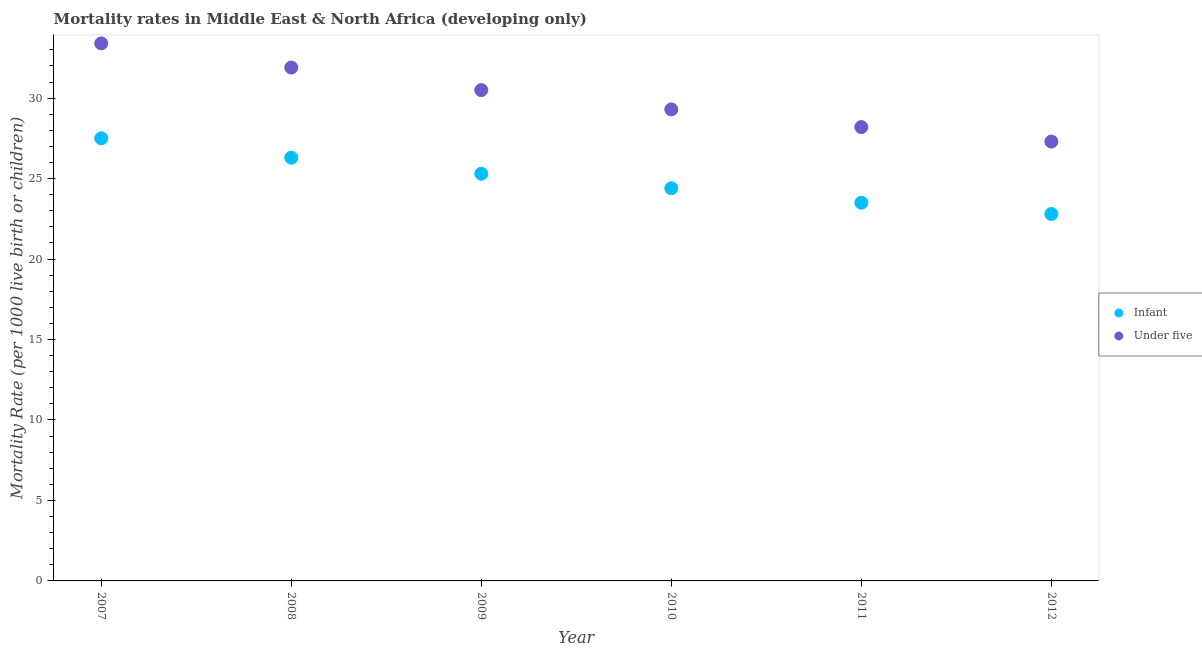How many different coloured dotlines are there?
Keep it short and to the point. 2. Is the number of dotlines equal to the number of legend labels?
Your response must be concise. Yes. What is the under-5 mortality rate in 2011?
Ensure brevity in your answer.  28.2. Across all years, what is the maximum under-5 mortality rate?
Your response must be concise. 33.4. Across all years, what is the minimum under-5 mortality rate?
Provide a short and direct response. 27.3. In which year was the infant mortality rate maximum?
Keep it short and to the point. 2007. What is the total under-5 mortality rate in the graph?
Your answer should be compact. 180.6. What is the difference between the under-5 mortality rate in 2008 and that in 2012?
Your answer should be compact. 4.6. What is the average infant mortality rate per year?
Make the answer very short. 24.97. In the year 2011, what is the difference between the infant mortality rate and under-5 mortality rate?
Make the answer very short. -4.7. In how many years, is the under-5 mortality rate greater than 10?
Provide a succinct answer. 6. What is the ratio of the under-5 mortality rate in 2008 to that in 2009?
Keep it short and to the point. 1.05. Is the difference between the under-5 mortality rate in 2008 and 2011 greater than the difference between the infant mortality rate in 2008 and 2011?
Provide a short and direct response. Yes. What is the difference between the highest and the second highest infant mortality rate?
Offer a very short reply. 1.2. What is the difference between the highest and the lowest under-5 mortality rate?
Your answer should be very brief. 6.1. In how many years, is the under-5 mortality rate greater than the average under-5 mortality rate taken over all years?
Your answer should be very brief. 3. Is the sum of the under-5 mortality rate in 2008 and 2009 greater than the maximum infant mortality rate across all years?
Make the answer very short. Yes. Does the infant mortality rate monotonically increase over the years?
Your answer should be very brief. No. Is the under-5 mortality rate strictly greater than the infant mortality rate over the years?
Ensure brevity in your answer.  Yes. How many dotlines are there?
Ensure brevity in your answer.  2. How many years are there in the graph?
Make the answer very short. 6. How are the legend labels stacked?
Give a very brief answer. Vertical. What is the title of the graph?
Give a very brief answer. Mortality rates in Middle East & North Africa (developing only). Does "2012 US$" appear as one of the legend labels in the graph?
Your response must be concise. No. What is the label or title of the Y-axis?
Ensure brevity in your answer.  Mortality Rate (per 1000 live birth or children). What is the Mortality Rate (per 1000 live birth or children) in Under five in 2007?
Your response must be concise. 33.4. What is the Mortality Rate (per 1000 live birth or children) of Infant in 2008?
Give a very brief answer. 26.3. What is the Mortality Rate (per 1000 live birth or children) in Under five in 2008?
Offer a terse response. 31.9. What is the Mortality Rate (per 1000 live birth or children) in Infant in 2009?
Your response must be concise. 25.3. What is the Mortality Rate (per 1000 live birth or children) of Under five in 2009?
Make the answer very short. 30.5. What is the Mortality Rate (per 1000 live birth or children) in Infant in 2010?
Keep it short and to the point. 24.4. What is the Mortality Rate (per 1000 live birth or children) of Under five in 2010?
Your response must be concise. 29.3. What is the Mortality Rate (per 1000 live birth or children) in Infant in 2011?
Give a very brief answer. 23.5. What is the Mortality Rate (per 1000 live birth or children) of Under five in 2011?
Offer a very short reply. 28.2. What is the Mortality Rate (per 1000 live birth or children) in Infant in 2012?
Ensure brevity in your answer.  22.8. What is the Mortality Rate (per 1000 live birth or children) in Under five in 2012?
Your answer should be compact. 27.3. Across all years, what is the maximum Mortality Rate (per 1000 live birth or children) of Infant?
Offer a very short reply. 27.5. Across all years, what is the maximum Mortality Rate (per 1000 live birth or children) of Under five?
Ensure brevity in your answer.  33.4. Across all years, what is the minimum Mortality Rate (per 1000 live birth or children) in Infant?
Provide a short and direct response. 22.8. Across all years, what is the minimum Mortality Rate (per 1000 live birth or children) in Under five?
Offer a very short reply. 27.3. What is the total Mortality Rate (per 1000 live birth or children) of Infant in the graph?
Your answer should be compact. 149.8. What is the total Mortality Rate (per 1000 live birth or children) in Under five in the graph?
Keep it short and to the point. 180.6. What is the difference between the Mortality Rate (per 1000 live birth or children) of Under five in 2007 and that in 2008?
Provide a succinct answer. 1.5. What is the difference between the Mortality Rate (per 1000 live birth or children) in Infant in 2007 and that in 2010?
Your answer should be very brief. 3.1. What is the difference between the Mortality Rate (per 1000 live birth or children) in Under five in 2007 and that in 2010?
Give a very brief answer. 4.1. What is the difference between the Mortality Rate (per 1000 live birth or children) of Under five in 2007 and that in 2011?
Make the answer very short. 5.2. What is the difference between the Mortality Rate (per 1000 live birth or children) of Infant in 2007 and that in 2012?
Give a very brief answer. 4.7. What is the difference between the Mortality Rate (per 1000 live birth or children) of Under five in 2007 and that in 2012?
Ensure brevity in your answer.  6.1. What is the difference between the Mortality Rate (per 1000 live birth or children) in Infant in 2008 and that in 2009?
Provide a succinct answer. 1. What is the difference between the Mortality Rate (per 1000 live birth or children) of Infant in 2008 and that in 2010?
Your answer should be compact. 1.9. What is the difference between the Mortality Rate (per 1000 live birth or children) of Under five in 2008 and that in 2010?
Your answer should be very brief. 2.6. What is the difference between the Mortality Rate (per 1000 live birth or children) in Under five in 2008 and that in 2011?
Make the answer very short. 3.7. What is the difference between the Mortality Rate (per 1000 live birth or children) of Infant in 2008 and that in 2012?
Your answer should be compact. 3.5. What is the difference between the Mortality Rate (per 1000 live birth or children) of Under five in 2009 and that in 2010?
Give a very brief answer. 1.2. What is the difference between the Mortality Rate (per 1000 live birth or children) in Infant in 2009 and that in 2011?
Make the answer very short. 1.8. What is the difference between the Mortality Rate (per 1000 live birth or children) in Infant in 2009 and that in 2012?
Your answer should be very brief. 2.5. What is the difference between the Mortality Rate (per 1000 live birth or children) of Under five in 2009 and that in 2012?
Your answer should be compact. 3.2. What is the difference between the Mortality Rate (per 1000 live birth or children) of Infant in 2010 and that in 2012?
Your response must be concise. 1.6. What is the difference between the Mortality Rate (per 1000 live birth or children) in Under five in 2010 and that in 2012?
Your answer should be compact. 2. What is the difference between the Mortality Rate (per 1000 live birth or children) of Infant in 2011 and that in 2012?
Provide a succinct answer. 0.7. What is the difference between the Mortality Rate (per 1000 live birth or children) of Infant in 2007 and the Mortality Rate (per 1000 live birth or children) of Under five in 2008?
Give a very brief answer. -4.4. What is the difference between the Mortality Rate (per 1000 live birth or children) of Infant in 2007 and the Mortality Rate (per 1000 live birth or children) of Under five in 2010?
Offer a terse response. -1.8. What is the difference between the Mortality Rate (per 1000 live birth or children) of Infant in 2009 and the Mortality Rate (per 1000 live birth or children) of Under five in 2011?
Provide a short and direct response. -2.9. What is the difference between the Mortality Rate (per 1000 live birth or children) in Infant in 2009 and the Mortality Rate (per 1000 live birth or children) in Under five in 2012?
Make the answer very short. -2. What is the difference between the Mortality Rate (per 1000 live birth or children) of Infant in 2010 and the Mortality Rate (per 1000 live birth or children) of Under five in 2011?
Give a very brief answer. -3.8. What is the average Mortality Rate (per 1000 live birth or children) in Infant per year?
Ensure brevity in your answer.  24.97. What is the average Mortality Rate (per 1000 live birth or children) in Under five per year?
Ensure brevity in your answer.  30.1. In the year 2007, what is the difference between the Mortality Rate (per 1000 live birth or children) of Infant and Mortality Rate (per 1000 live birth or children) of Under five?
Ensure brevity in your answer.  -5.9. In the year 2008, what is the difference between the Mortality Rate (per 1000 live birth or children) in Infant and Mortality Rate (per 1000 live birth or children) in Under five?
Your answer should be compact. -5.6. In the year 2009, what is the difference between the Mortality Rate (per 1000 live birth or children) of Infant and Mortality Rate (per 1000 live birth or children) of Under five?
Ensure brevity in your answer.  -5.2. In the year 2010, what is the difference between the Mortality Rate (per 1000 live birth or children) of Infant and Mortality Rate (per 1000 live birth or children) of Under five?
Keep it short and to the point. -4.9. What is the ratio of the Mortality Rate (per 1000 live birth or children) of Infant in 2007 to that in 2008?
Your response must be concise. 1.05. What is the ratio of the Mortality Rate (per 1000 live birth or children) of Under five in 2007 to that in 2008?
Make the answer very short. 1.05. What is the ratio of the Mortality Rate (per 1000 live birth or children) of Infant in 2007 to that in 2009?
Your answer should be very brief. 1.09. What is the ratio of the Mortality Rate (per 1000 live birth or children) in Under five in 2007 to that in 2009?
Offer a terse response. 1.1. What is the ratio of the Mortality Rate (per 1000 live birth or children) in Infant in 2007 to that in 2010?
Your response must be concise. 1.13. What is the ratio of the Mortality Rate (per 1000 live birth or children) of Under five in 2007 to that in 2010?
Keep it short and to the point. 1.14. What is the ratio of the Mortality Rate (per 1000 live birth or children) of Infant in 2007 to that in 2011?
Ensure brevity in your answer.  1.17. What is the ratio of the Mortality Rate (per 1000 live birth or children) in Under five in 2007 to that in 2011?
Your answer should be very brief. 1.18. What is the ratio of the Mortality Rate (per 1000 live birth or children) in Infant in 2007 to that in 2012?
Your answer should be compact. 1.21. What is the ratio of the Mortality Rate (per 1000 live birth or children) of Under five in 2007 to that in 2012?
Provide a short and direct response. 1.22. What is the ratio of the Mortality Rate (per 1000 live birth or children) in Infant in 2008 to that in 2009?
Provide a short and direct response. 1.04. What is the ratio of the Mortality Rate (per 1000 live birth or children) in Under five in 2008 to that in 2009?
Offer a terse response. 1.05. What is the ratio of the Mortality Rate (per 1000 live birth or children) in Infant in 2008 to that in 2010?
Provide a short and direct response. 1.08. What is the ratio of the Mortality Rate (per 1000 live birth or children) in Under five in 2008 to that in 2010?
Your response must be concise. 1.09. What is the ratio of the Mortality Rate (per 1000 live birth or children) in Infant in 2008 to that in 2011?
Make the answer very short. 1.12. What is the ratio of the Mortality Rate (per 1000 live birth or children) in Under five in 2008 to that in 2011?
Ensure brevity in your answer.  1.13. What is the ratio of the Mortality Rate (per 1000 live birth or children) in Infant in 2008 to that in 2012?
Your answer should be compact. 1.15. What is the ratio of the Mortality Rate (per 1000 live birth or children) of Under five in 2008 to that in 2012?
Your response must be concise. 1.17. What is the ratio of the Mortality Rate (per 1000 live birth or children) of Infant in 2009 to that in 2010?
Offer a very short reply. 1.04. What is the ratio of the Mortality Rate (per 1000 live birth or children) in Under five in 2009 to that in 2010?
Provide a succinct answer. 1.04. What is the ratio of the Mortality Rate (per 1000 live birth or children) in Infant in 2009 to that in 2011?
Provide a short and direct response. 1.08. What is the ratio of the Mortality Rate (per 1000 live birth or children) in Under five in 2009 to that in 2011?
Provide a succinct answer. 1.08. What is the ratio of the Mortality Rate (per 1000 live birth or children) of Infant in 2009 to that in 2012?
Ensure brevity in your answer.  1.11. What is the ratio of the Mortality Rate (per 1000 live birth or children) of Under five in 2009 to that in 2012?
Keep it short and to the point. 1.12. What is the ratio of the Mortality Rate (per 1000 live birth or children) in Infant in 2010 to that in 2011?
Offer a terse response. 1.04. What is the ratio of the Mortality Rate (per 1000 live birth or children) of Under five in 2010 to that in 2011?
Give a very brief answer. 1.04. What is the ratio of the Mortality Rate (per 1000 live birth or children) of Infant in 2010 to that in 2012?
Ensure brevity in your answer.  1.07. What is the ratio of the Mortality Rate (per 1000 live birth or children) in Under five in 2010 to that in 2012?
Your answer should be compact. 1.07. What is the ratio of the Mortality Rate (per 1000 live birth or children) in Infant in 2011 to that in 2012?
Keep it short and to the point. 1.03. What is the ratio of the Mortality Rate (per 1000 live birth or children) of Under five in 2011 to that in 2012?
Provide a succinct answer. 1.03. 